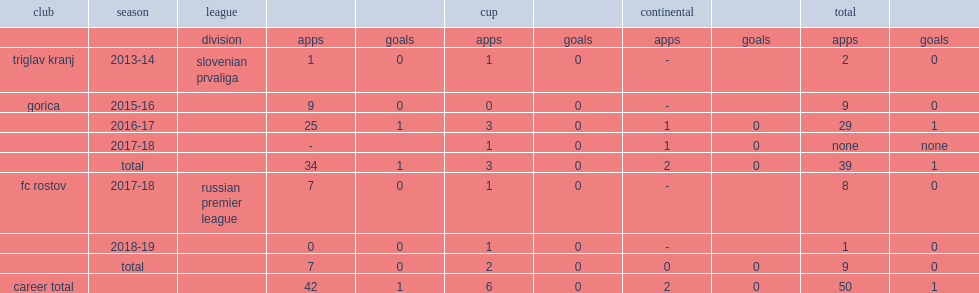Which club did matija boben join in the slovenian prvaliga in the 2013-14 season? Triglav kranj. 